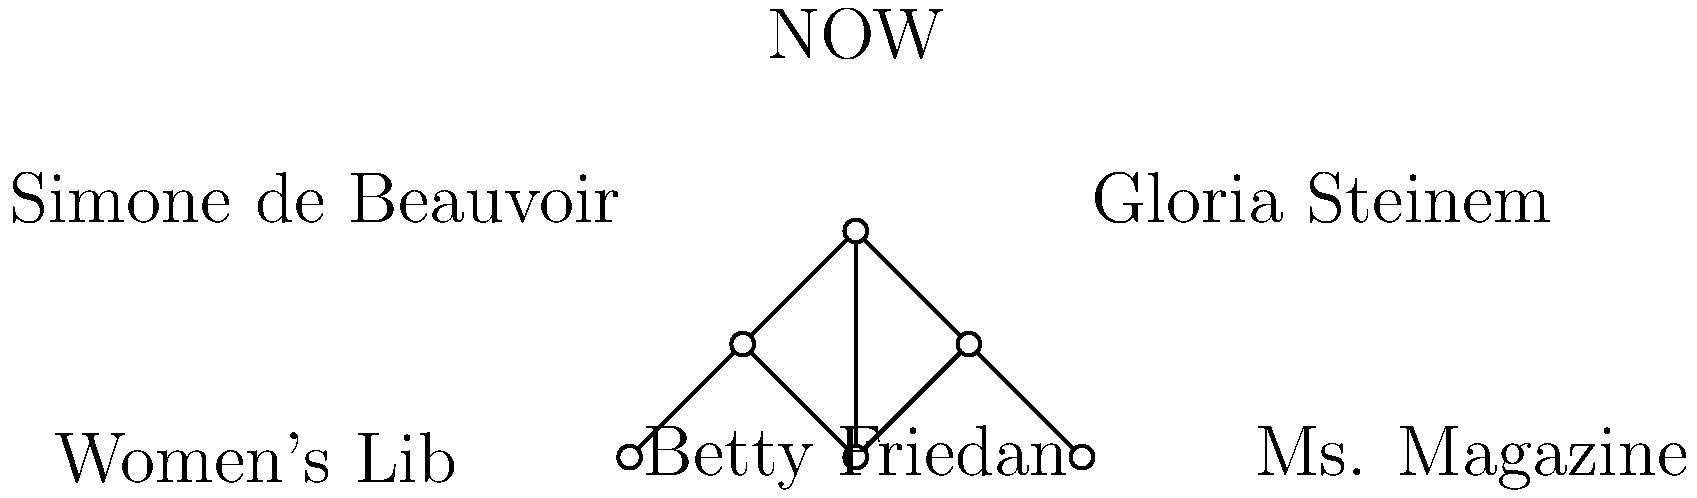Based on the network diagram showing connections between influential feminist leaders and organizations, which individual appears to have the most direct connections, and what does this suggest about their role in the women's movement? To answer this question, we need to analyze the network diagram and count the connections for each individual:

1. Betty Friedan:
   - Connected to Gloria Steinem
   - Connected to Simone de Beauvoir
   - Connected to NOW (National Organization for Women)
   Total: 3 connections

2. Gloria Steinem:
   - Connected to Betty Friedan
   - Connected to NOW
   - Connected to Ms. Magazine
   Total: 3 connections

3. Simone de Beauvoir:
   - Connected to Betty Friedan
   - Connected to Women's Lib
   Total: 2 connections

Analyzing the organizations:
4. NOW:
   - Connected to Betty Friedan
   - Connected to Gloria Steinem
   - Connected to Women's Lib
   - Connected to Ms. Magazine
   Total: 4 connections

5. Women's Lib:
   - Connected to Simone de Beauvoir
   - Connected to NOW
   Total: 2 connections

6. Ms. Magazine:
   - Connected to Gloria Steinem
   - Connected to NOW
   Total: 2 connections

Betty Friedan and Gloria Steinem both have the most direct connections among individuals (3 each). However, the organization NOW has the most overall connections (4).

This suggests that Betty Friedan and Gloria Steinem were central figures in connecting various aspects of the women's movement. Their multiple connections indicate they likely played pivotal roles in bridging different feminist leaders and organizations.

The prominence of NOW in the network, with connections to both key individuals and other organizations, suggests it was a central hub for feminist activity and collaboration during this period of the women's movement.
Answer: Betty Friedan and Gloria Steinem (3 connections each); central roles in connecting different aspects of the women's movement. 